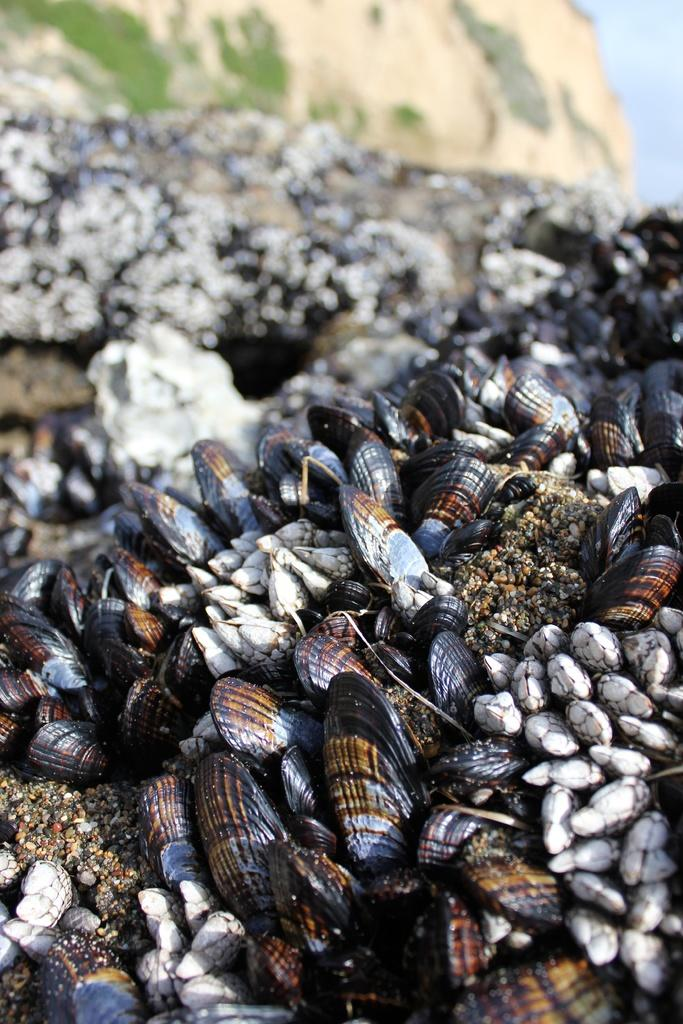What type of objects are present in the image? There are colored stones in the image. Can you describe the appearance of the stones? The stones have different colors in the image. How does the zebra grip the pie in the image? There is no zebra or pie present in the image; it only features colored stones. 